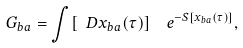Convert formula to latex. <formula><loc_0><loc_0><loc_500><loc_500>G _ { b a } = \int [ \ D x _ { b a } ( \tau ) ] \ \ e ^ { - S [ x _ { b a } ( \tau ) ] } ,</formula> 